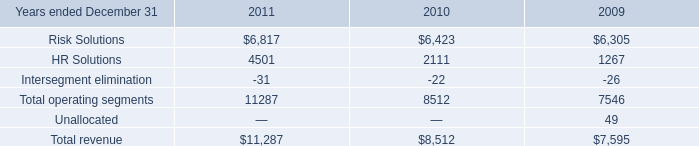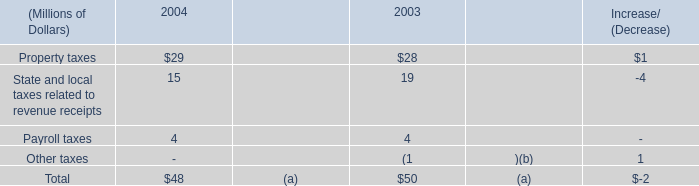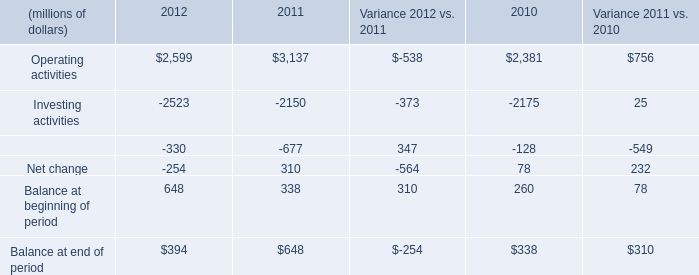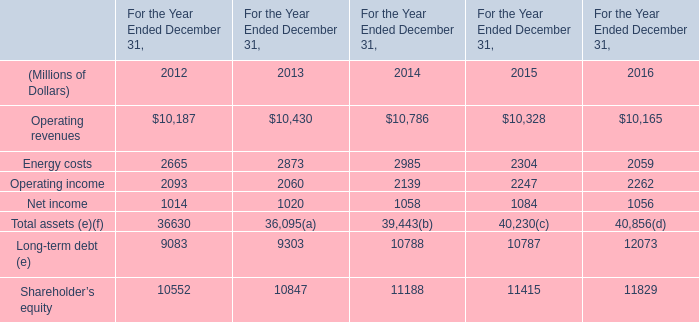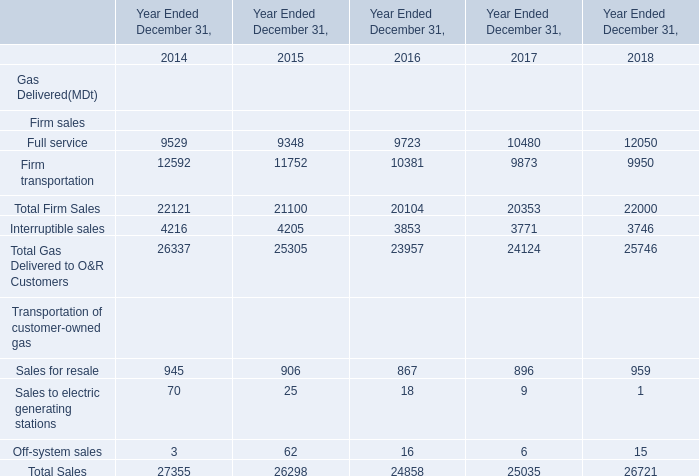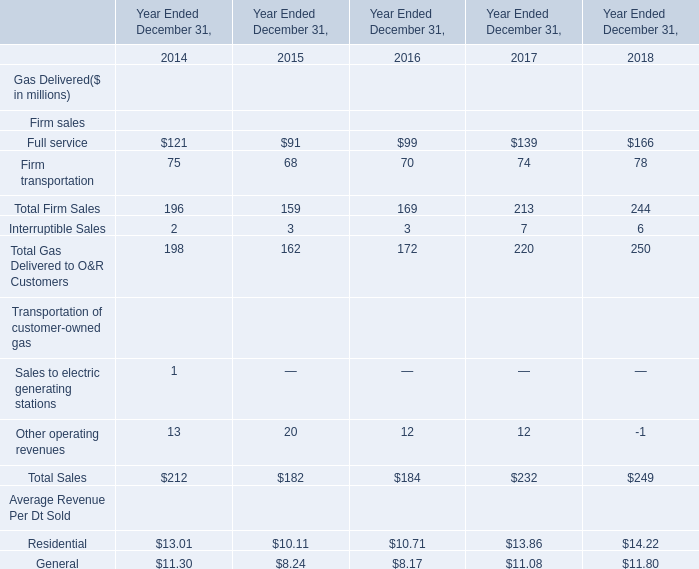Which year is Off-system sales greater than 15 ? 
Answer: 2015;2016. 